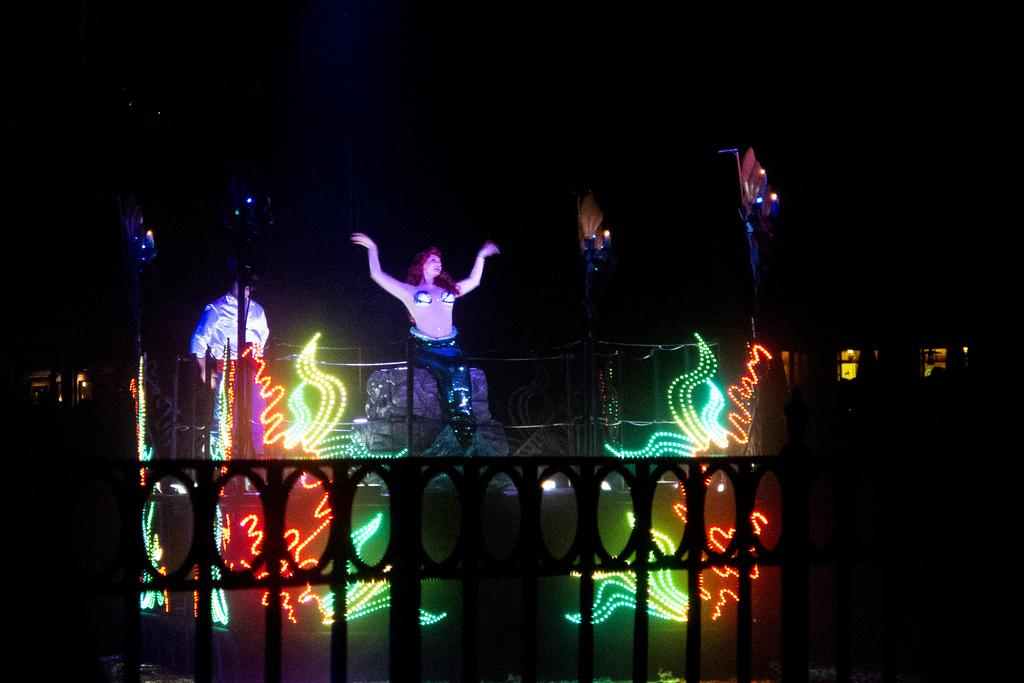What is the woman in the image doing? The woman is dancing in the image. What type of architectural feature can be seen in the image? There are iron grills in the image. What natural phenomenon is visible in the image? Lightnings are visible in the image. How would you describe the overall lighting in the image? The background appears dark in the image. Can you identify another person in the image besides the dancing woman? Yes, there is a person standing in the image. What type of cat is sitting on the uncle's lap in the image? There is no uncle or cat present in the image; it features a woman dancing and a person standing. Is the dancing woman in the image a fictional character? The dancing woman in the image is not a fictional character; she is a real person. 